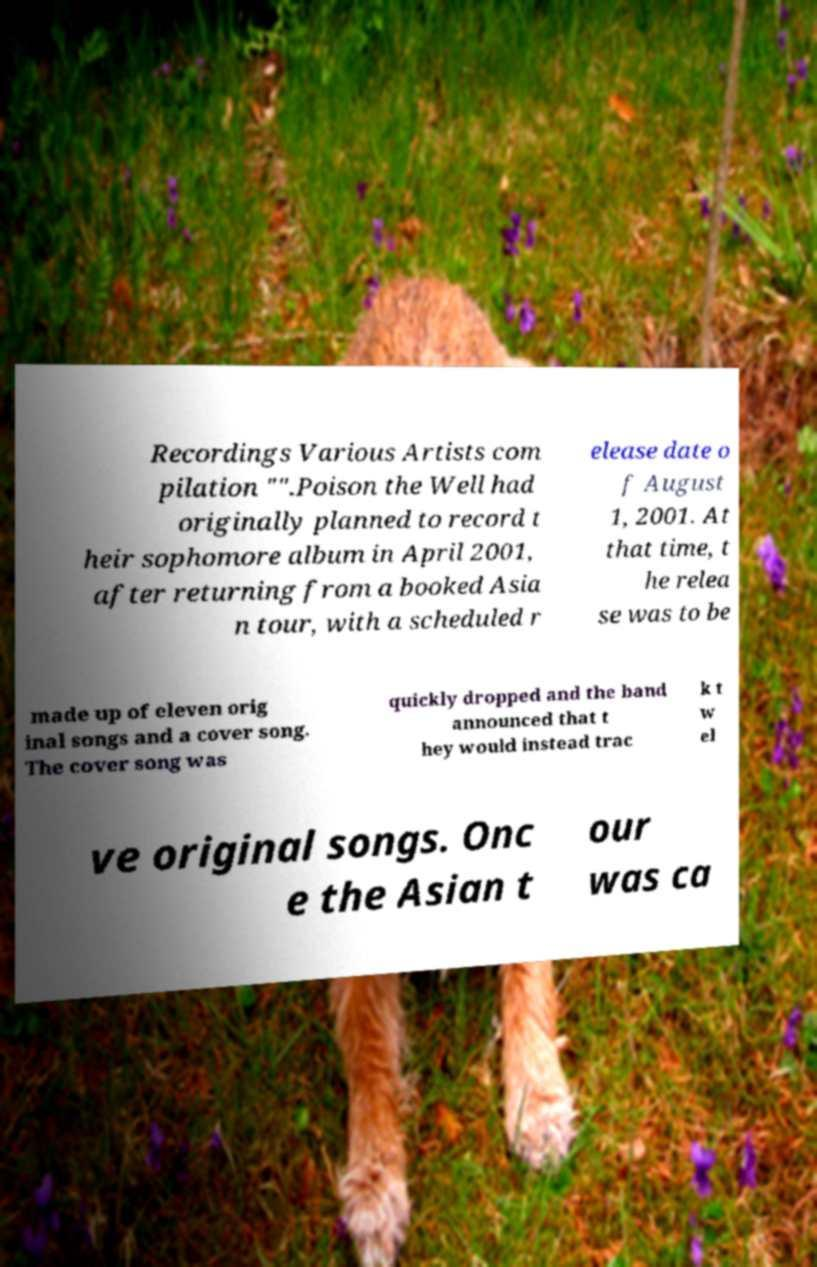Could you extract and type out the text from this image? Recordings Various Artists com pilation "".Poison the Well had originally planned to record t heir sophomore album in April 2001, after returning from a booked Asia n tour, with a scheduled r elease date o f August 1, 2001. At that time, t he relea se was to be made up of eleven orig inal songs and a cover song. The cover song was quickly dropped and the band announced that t hey would instead trac k t w el ve original songs. Onc e the Asian t our was ca 